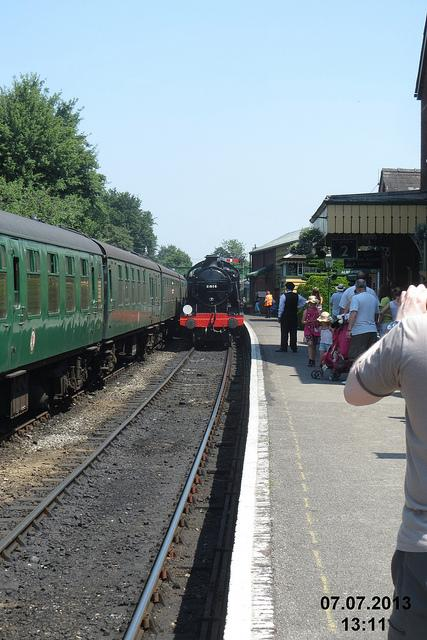How many days after the Independence Day was this picture taken? Please explain your reasoning. three. The photo was taken three days after july 4. 